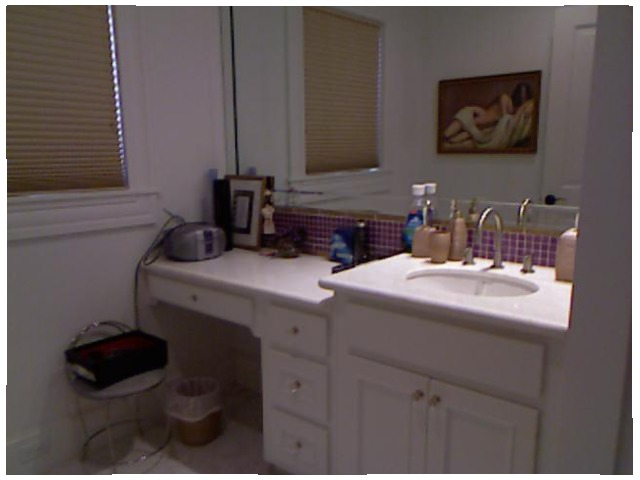<image>
Can you confirm if the tap is under the photo frame? No. The tap is not positioned under the photo frame. The vertical relationship between these objects is different. Where is the can in relation to the painting? Is it in front of the painting? Yes. The can is positioned in front of the painting, appearing closer to the camera viewpoint. Where is the painting in relation to the mirror? Is it in the mirror? Yes. The painting is contained within or inside the mirror, showing a containment relationship. 